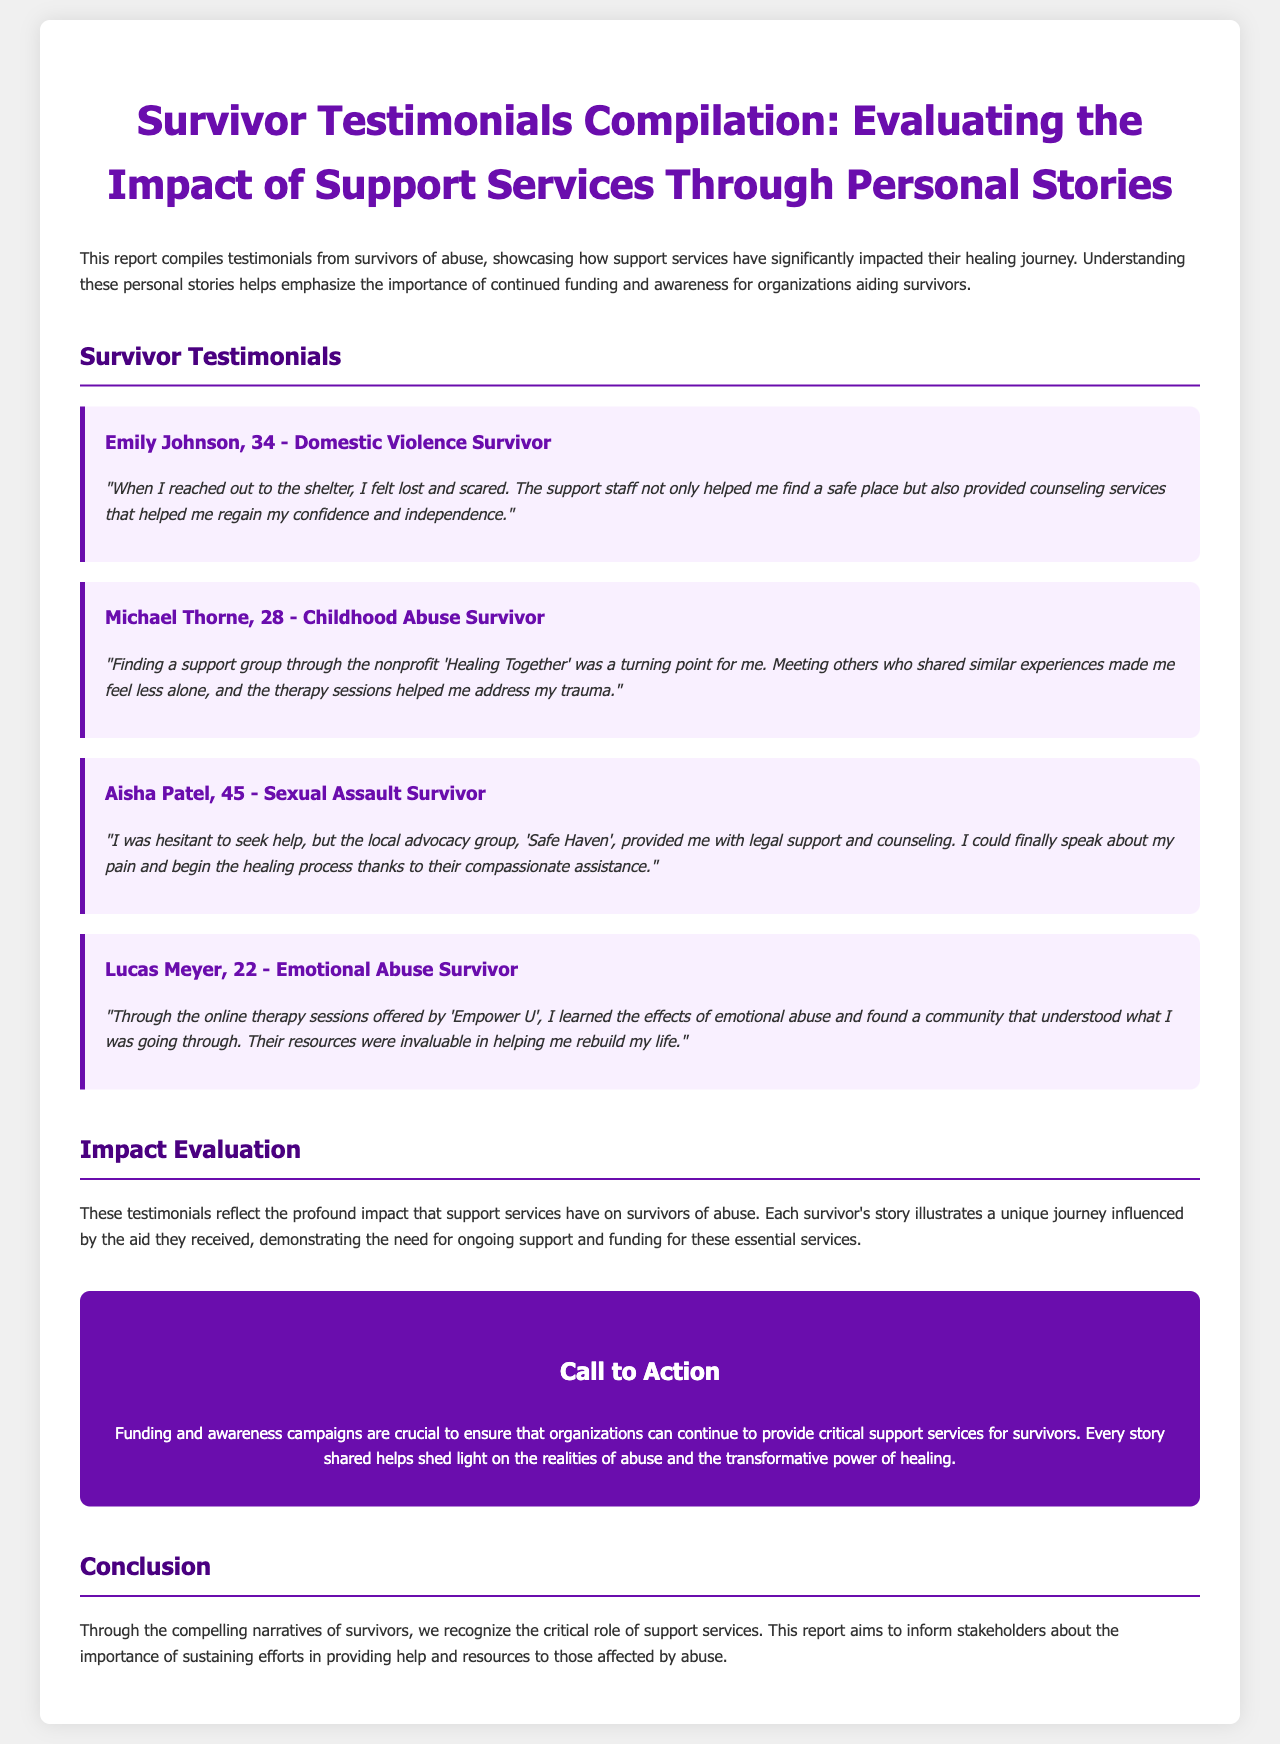What is the title of the report? The title of the report is mentioned at the beginning of the document.
Answer: Survivor Testimonials Compilation: Evaluating the Impact of Support Services Through Personal Stories How many survivor testimonials are featured in the report? The report lists four individual testimonials from survivors, which can be counted from the document.
Answer: Four Who is a survivor of domestic violence according to the report? "Emily Johnson" is the individual mentioned as a survivor of domestic violence in the testimonials section.
Answer: Emily Johnson What organization helped Michael Thorne? The nonprofit organization mentioned that helped him is 'Healing Together'.
Answer: Healing Together What type of support did Aisha Patel receive? The document specifies that she received legal support and counseling, illustrating the assistance provided by an advocacy group.
Answer: Legal support and counseling How did Lucas Meyer feel about his experience with 'Empower U'? His experience is summarized by the positive impact of learning about emotional abuse and finding a supportive community.
Answer: Invaluable What does the report emphasize as critical for organizations providing support services? The report highlights the importance of funding and awareness campaigns for organizations like those mentioned.
Answer: Funding and awareness campaigns What is the aim of the report? The report's goal is stated as informing stakeholders about sustaining efforts for providing help and resources to those affected by abuse.
Answer: Inform stakeholders What is the color scheme used for the testimonials section? The testimonials are presented with backgrounds in light purple shades and borders in a specific color.
Answer: Light purple 